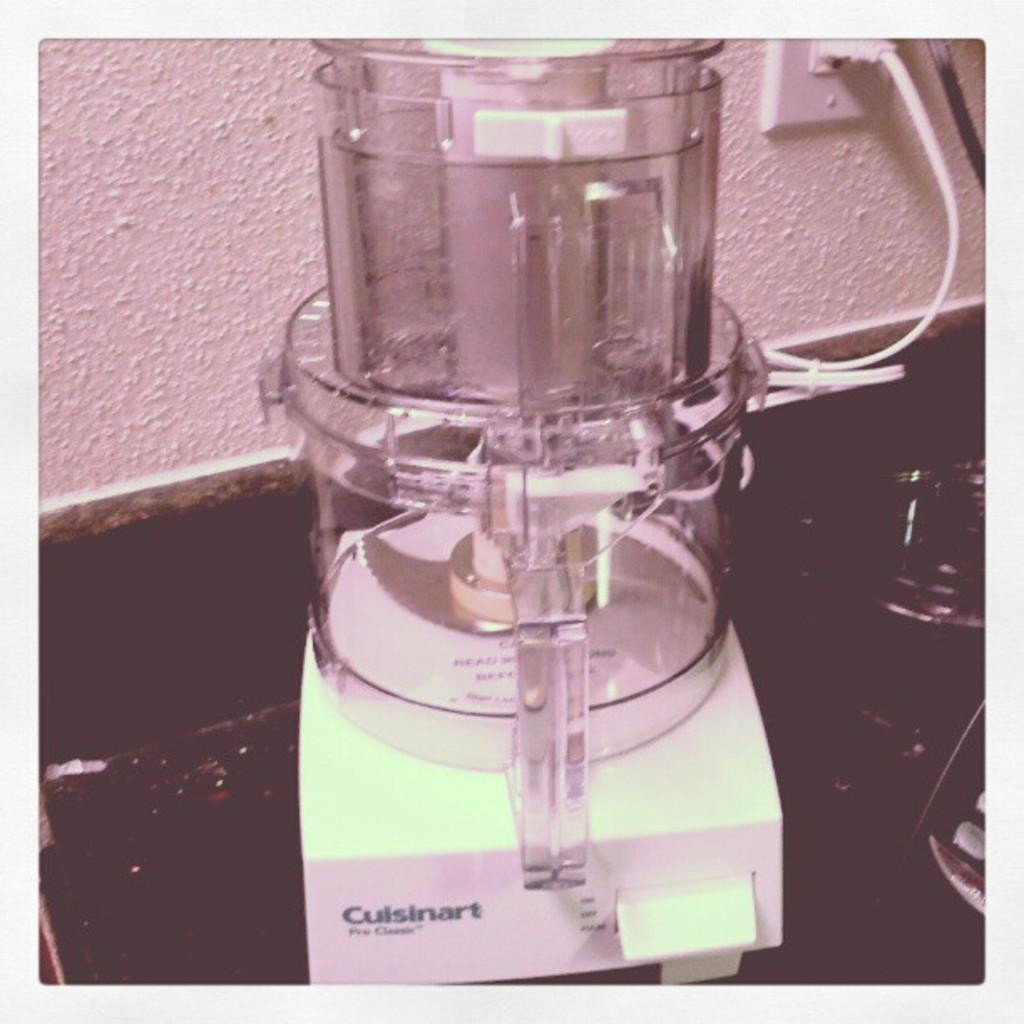<image>
Present a compact description of the photo's key features. a machine that has a logo that says 'cuisinart' on it 